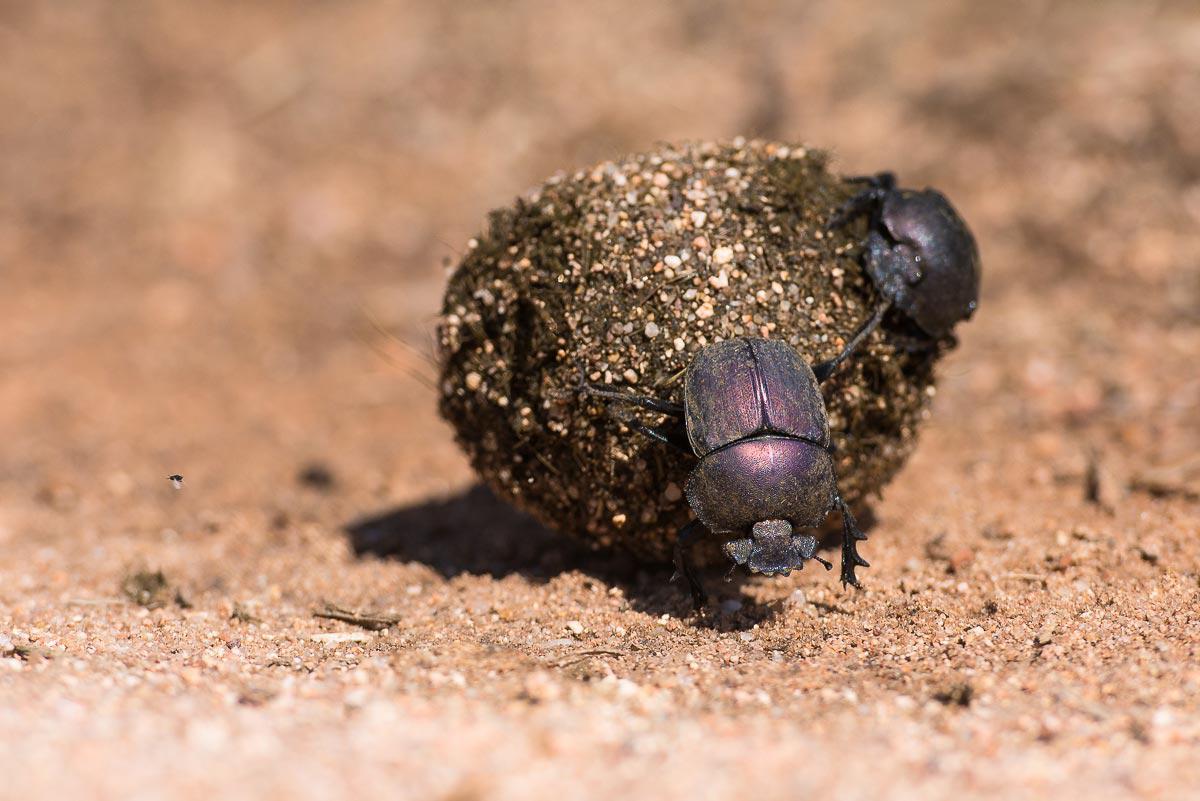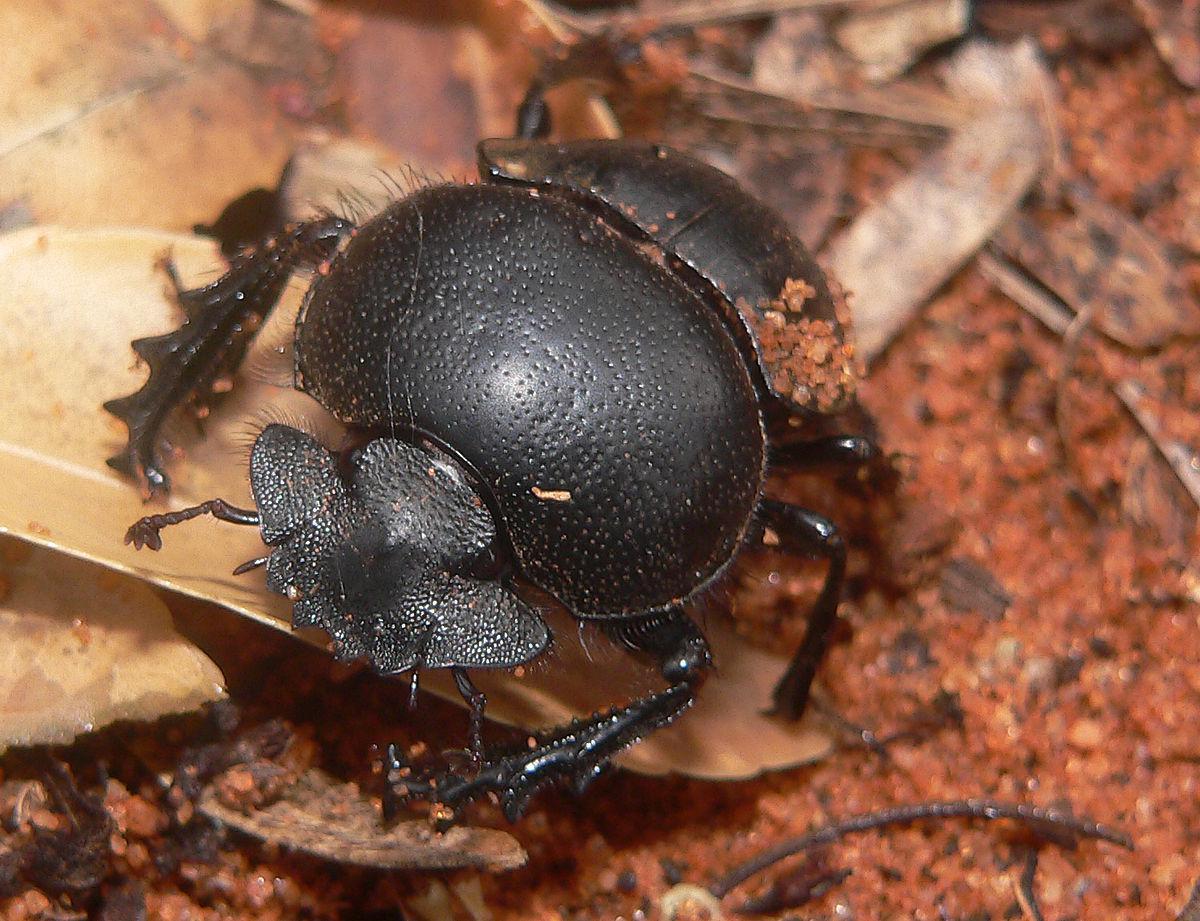The first image is the image on the left, the second image is the image on the right. For the images shown, is this caption "There is exactly one insect in the image on the left." true? Answer yes or no. No. 